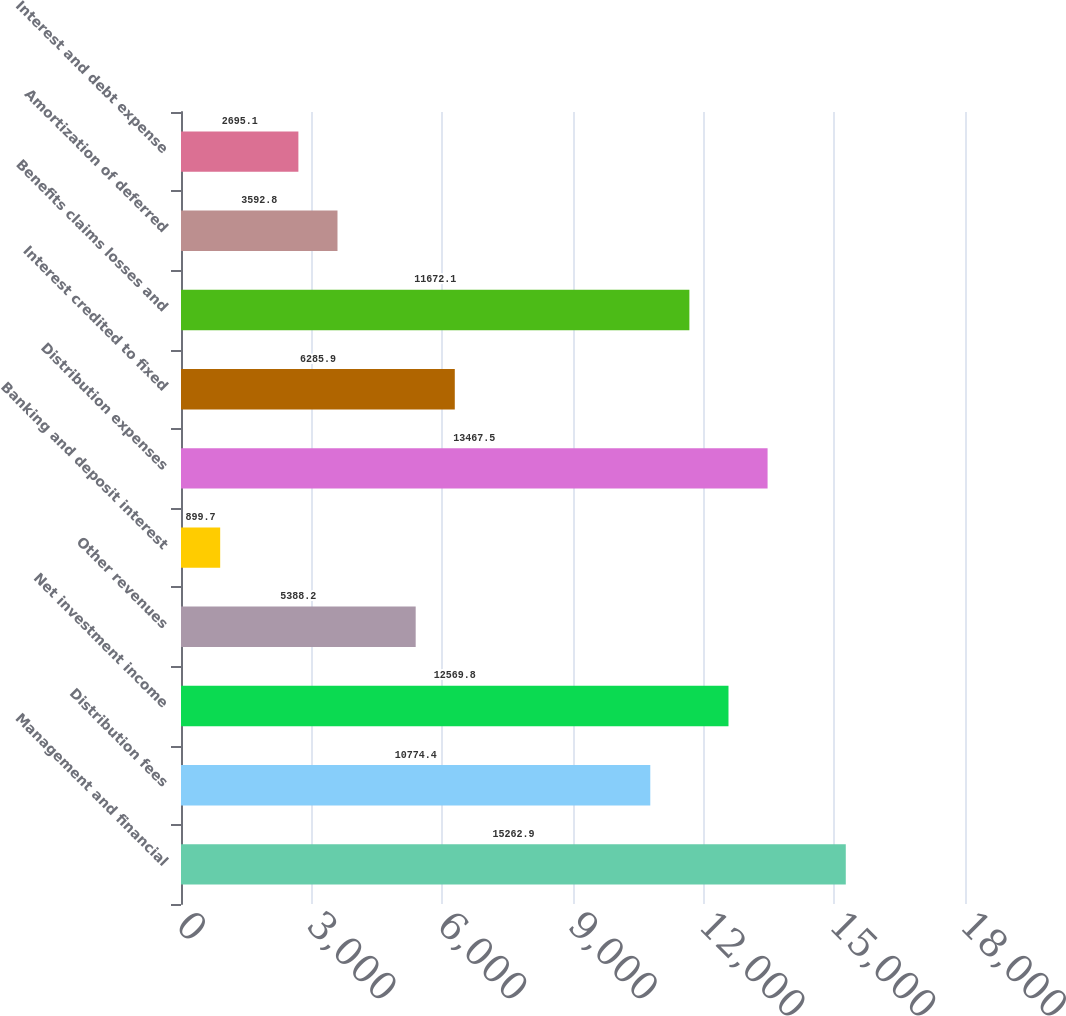<chart> <loc_0><loc_0><loc_500><loc_500><bar_chart><fcel>Management and financial<fcel>Distribution fees<fcel>Net investment income<fcel>Other revenues<fcel>Banking and deposit interest<fcel>Distribution expenses<fcel>Interest credited to fixed<fcel>Benefits claims losses and<fcel>Amortization of deferred<fcel>Interest and debt expense<nl><fcel>15262.9<fcel>10774.4<fcel>12569.8<fcel>5388.2<fcel>899.7<fcel>13467.5<fcel>6285.9<fcel>11672.1<fcel>3592.8<fcel>2695.1<nl></chart> 